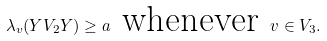<formula> <loc_0><loc_0><loc_500><loc_500>\lambda _ { v } ( Y V _ { 2 } Y ) \geq a \text {\ whenever\ } v \in V _ { 3 } .</formula> 